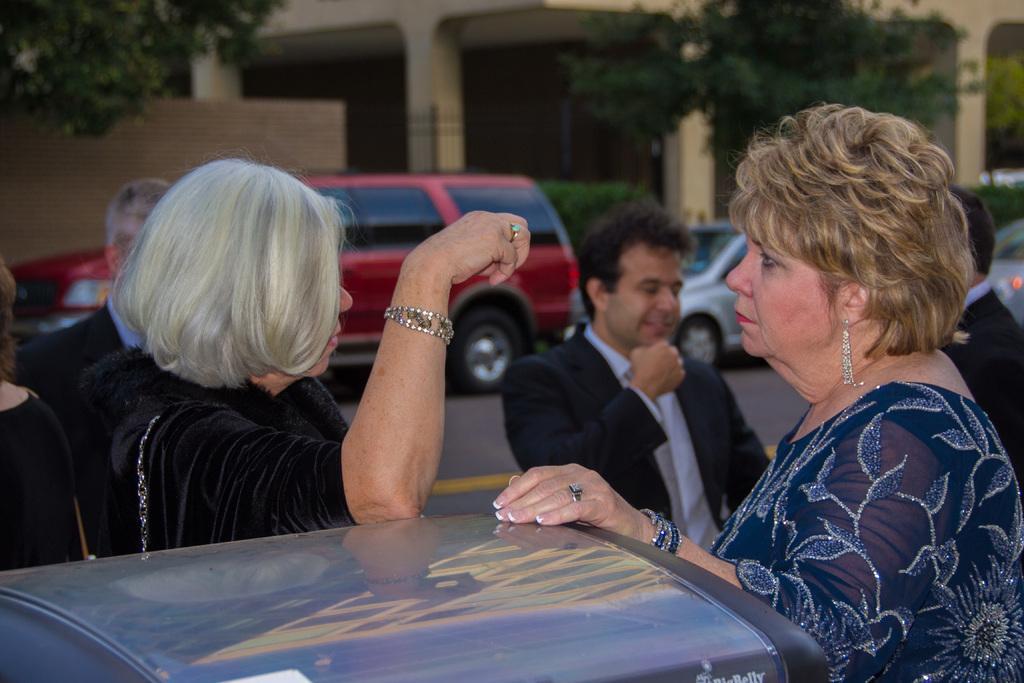How would you summarize this image in a sentence or two? This image is taken outdoors. In the background there is a building. There are few trees and there are few pillars. There is a wall and a few cars are parked on the road. At the bottom of the image a car is parked on the road. On the left side of the image a man and two women are standing on the road. On the right side of the image two men and a woman standing on the road. 